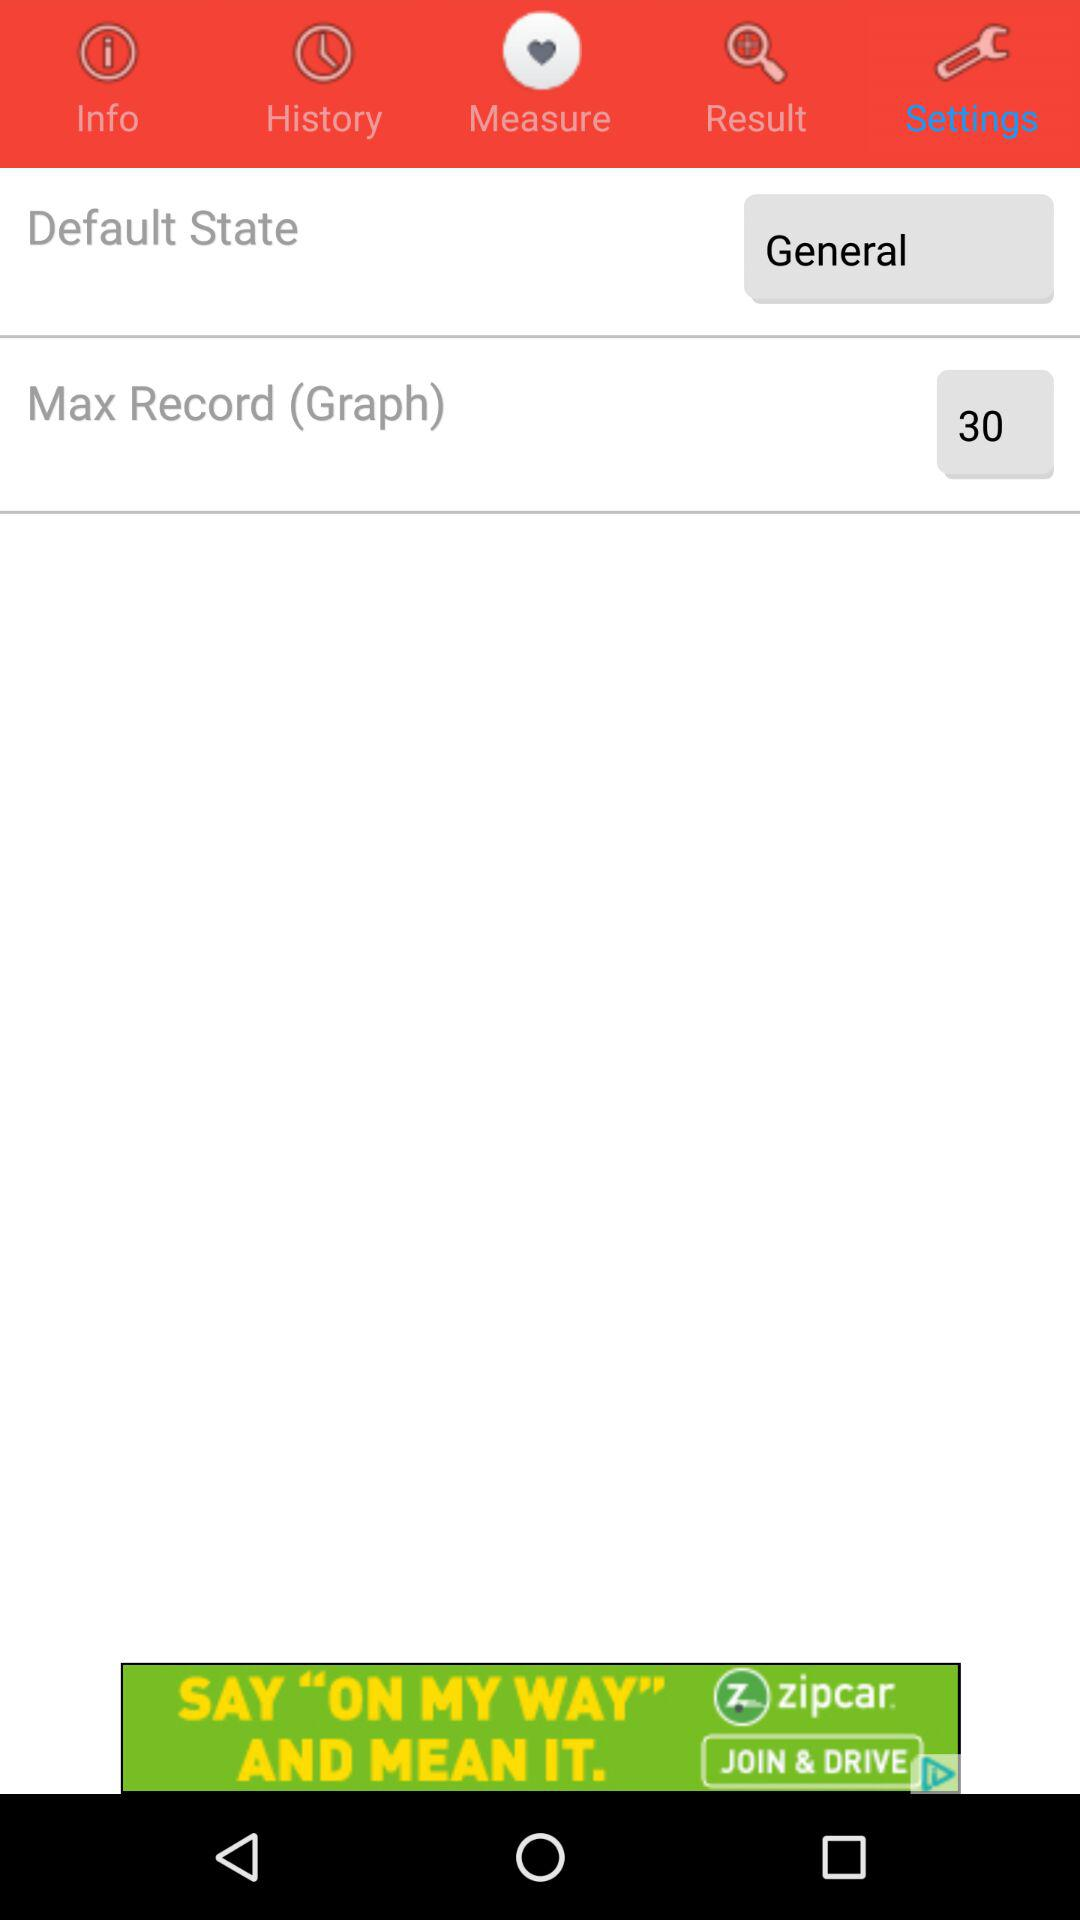What is the count of "Max Record (Graph)"? The count is 30. 